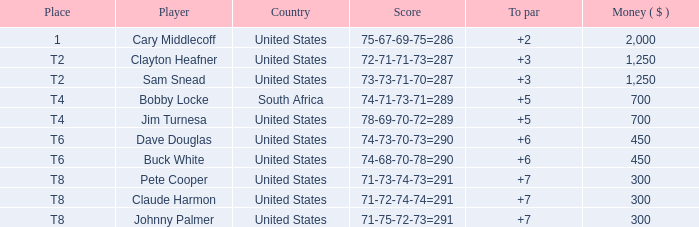What does claude harmon's place refer to? T8. 